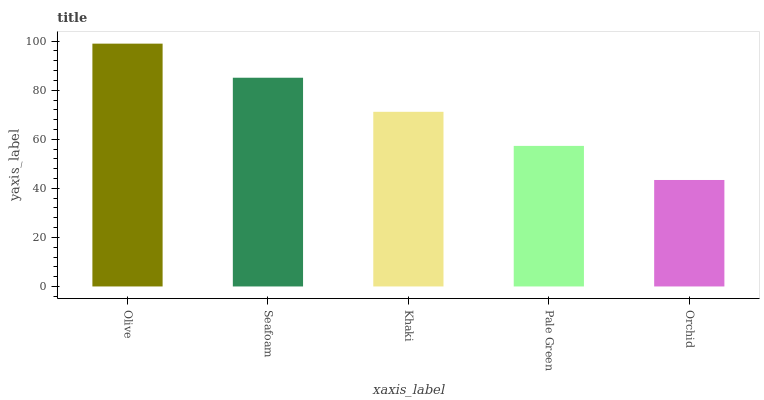Is Orchid the minimum?
Answer yes or no. Yes. Is Olive the maximum?
Answer yes or no. Yes. Is Seafoam the minimum?
Answer yes or no. No. Is Seafoam the maximum?
Answer yes or no. No. Is Olive greater than Seafoam?
Answer yes or no. Yes. Is Seafoam less than Olive?
Answer yes or no. Yes. Is Seafoam greater than Olive?
Answer yes or no. No. Is Olive less than Seafoam?
Answer yes or no. No. Is Khaki the high median?
Answer yes or no. Yes. Is Khaki the low median?
Answer yes or no. Yes. Is Orchid the high median?
Answer yes or no. No. Is Seafoam the low median?
Answer yes or no. No. 